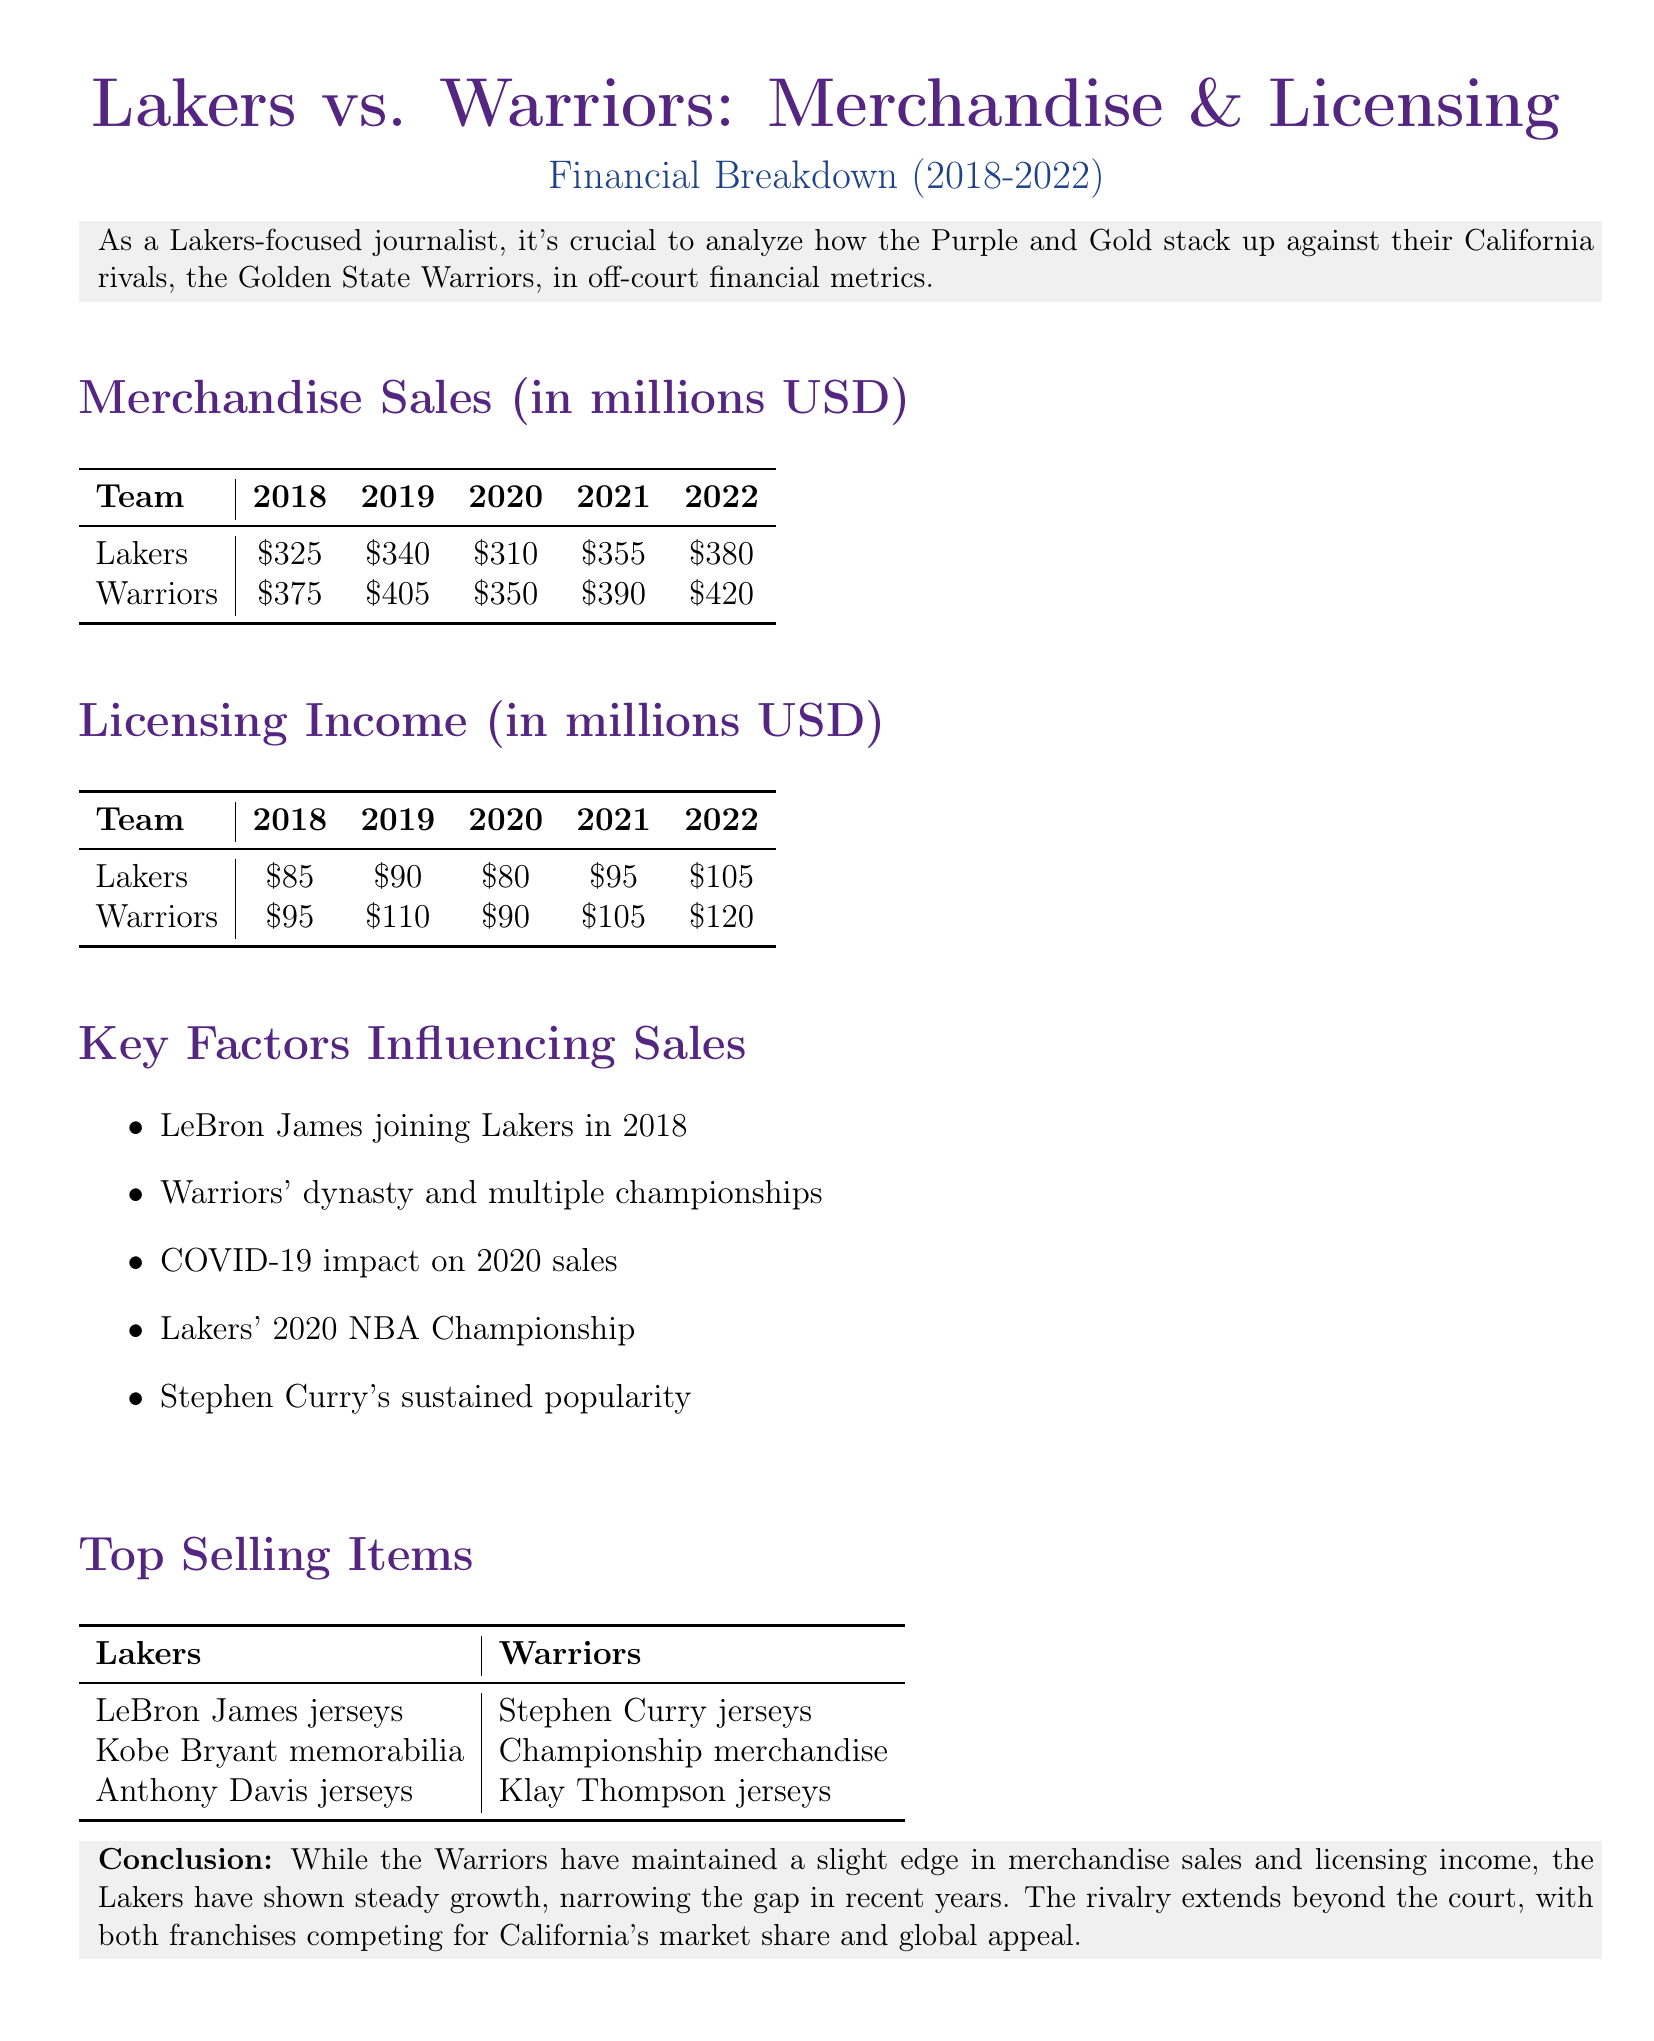What were the Lakers' merchandise sales in 2022? The merchandise sales for the Lakers in 2022 is directly stated in the document.
Answer: $380 million What was the licensing income of the Warriors in 2019? The document specifies the licensing income for the Warriors in 2019 in the respective section.
Answer: $110 million Which team had the highest merchandise sales in 2018? By comparing the merchandise sales data presented, it can be determined which team had higher sales in 2018.
Answer: Warriors How much did the Lakers' licensing income increase from 2018 to 2022? The increase can be calculated by subtracting the 2018 licensing income from the 2022 licensing income.
Answer: $20 million What were the top-selling items for the Lakers? The document lists the top-selling items for the Lakers in a dedicated section.
Answer: LeBron James jerseys, Kobe Bryant memorabilia, Anthony Davis jerseys Which key factor mentioned may have influenced the Warriors' merchandise sales? The document lists several key factors, and one of them can be identified as influencing the Warriors' performance.
Answer: Warriors' dynasty and multiple championships What was the impact of COVID-19 on merchandise sales? The document states that COVID-19 had an impact on sales, specifically focusing on a certain year.
Answer: Impact on 2020 sales What is the overall trend in Lakers' merchandise sales from 2018 to 2022? The document discusses the Lakers' growth trend over the years.
Answer: Steady growth In what year did the Lakers win the NBA Championship? The text refers to a specific year associated with a significant achievement for the Lakers.
Answer: 2020 